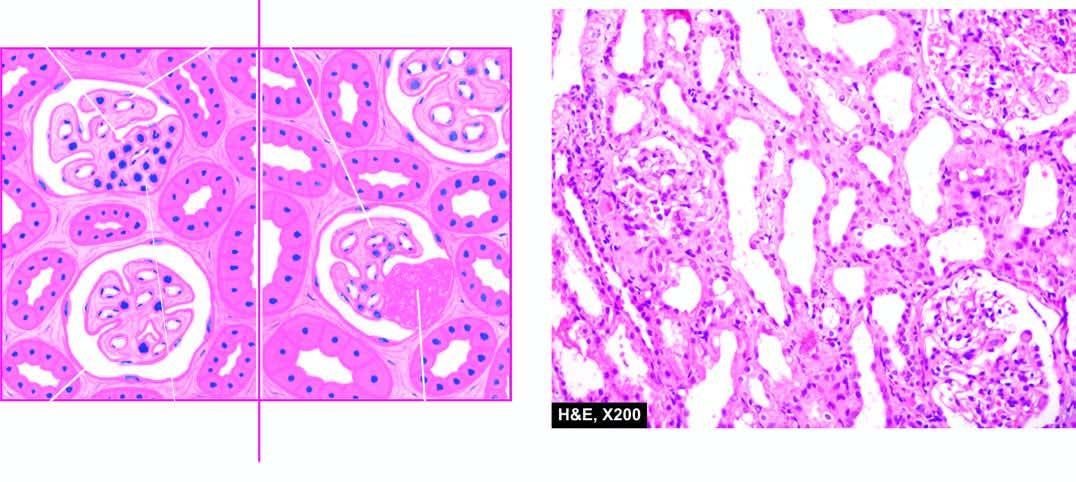what is the characteristic feature?
Answer the question using a single word or phrase. Cellular proliferation 